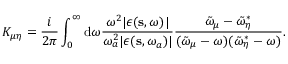Convert formula to latex. <formula><loc_0><loc_0><loc_500><loc_500>K _ { \mu \eta } = \frac { i } { 2 \pi } \int _ { 0 } ^ { \infty } { \mathrm d } \omega \frac { \omega ^ { 2 } | \epsilon ( \mathbf s , \omega ) | } { \omega _ { a } ^ { 2 } | \epsilon ( s , \omega _ { a } ) | } \frac { \tilde { \omega } _ { \mu } - \tilde { \omega } _ { \eta } ^ { * } } { ( \tilde { \omega } _ { \mu } - \omega ) ( \tilde { \omega } _ { \eta } ^ { * } - \omega ) } .</formula> 